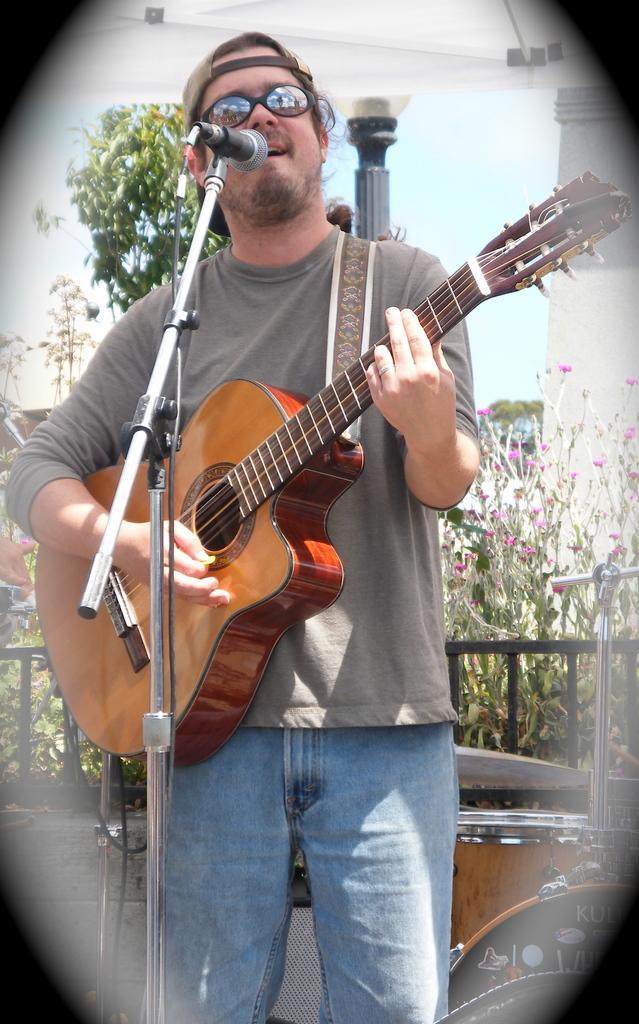Can you describe this image briefly? We can able to see person is playing guitar and singing in-front of a mic. Far there is a tree. This is a musical instrument. This is mic with holder. 